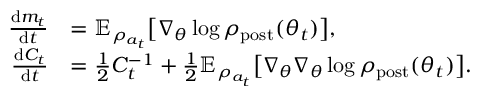Convert formula to latex. <formula><loc_0><loc_0><loc_500><loc_500>\begin{array} { r l } { \frac { d m _ { t } } { d t } } & { = \mathbb { E } _ { \rho _ { a _ { t } } } \left [ \nabla _ { \theta } \log \rho _ { p o s t } ( \theta _ { t } ) \right ] , } \\ { \frac { d C _ { t } } { d t } } & { = \frac { 1 } { 2 } C _ { t } ^ { - 1 } + \frac { 1 } { 2 } \mathbb { E } _ { \rho _ { a _ { t } } } \left [ \nabla _ { \theta } \nabla _ { \theta } \log \rho _ { p o s t } ( \theta _ { t } ) \right ] . } \end{array}</formula> 